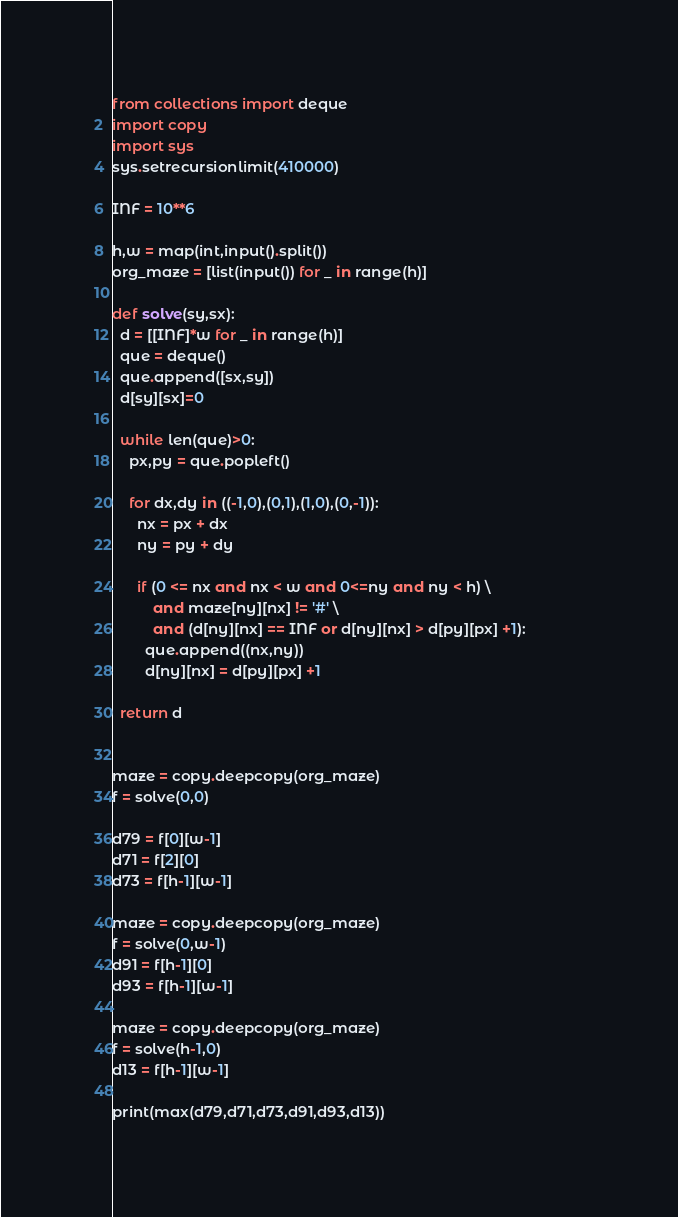<code> <loc_0><loc_0><loc_500><loc_500><_Python_>from collections import deque
import copy
import sys
sys.setrecursionlimit(410000)

INF = 10**6

h,w = map(int,input().split())
org_maze = [list(input()) for _ in range(h)]

def solve(sy,sx):
  d = [[INF]*w for _ in range(h)]
  que = deque()
  que.append([sx,sy])
  d[sy][sx]=0

  while len(que)>0:
    px,py = que.popleft()

    for dx,dy in ((-1,0),(0,1),(1,0),(0,-1)):
      nx = px + dx
      ny = py + dy

      if (0 <= nx and nx < w and 0<=ny and ny < h) \
          and maze[ny][nx] != '#' \
          and (d[ny][nx] == INF or d[ny][nx] > d[py][px] +1):              
        que.append((nx,ny))
        d[ny][nx] = d[py][px] +1

  return d


maze = copy.deepcopy(org_maze)
f = solve(0,0)

d79 = f[0][w-1]
d71 = f[2][0]
d73 = f[h-1][w-1]

maze = copy.deepcopy(org_maze)
f = solve(0,w-1)
d91 = f[h-1][0]
d93 = f[h-1][w-1]

maze = copy.deepcopy(org_maze)
f = solve(h-1,0)
d13 = f[h-1][w-1]

print(max(d79,d71,d73,d91,d93,d13))</code> 